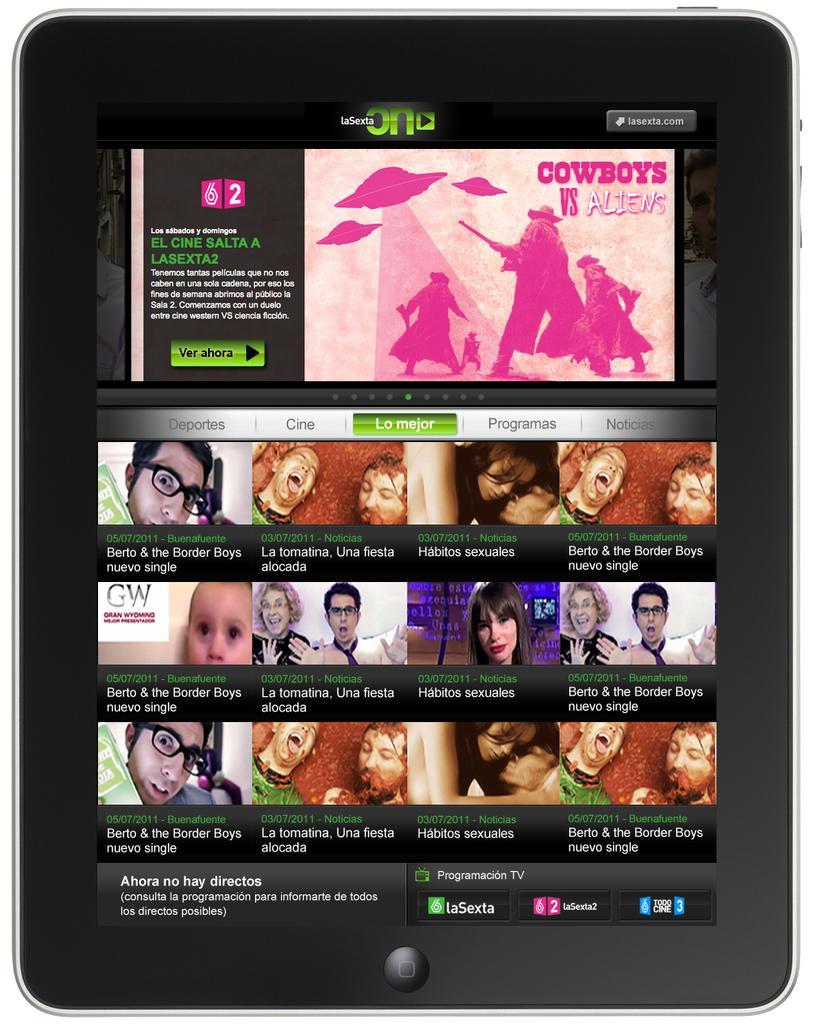Please provide a concise description of this image. In this image there is an electronic device and in the device we could see some text, persons and animation of some people. 